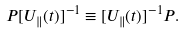Convert formula to latex. <formula><loc_0><loc_0><loc_500><loc_500>P [ U _ { \| } ( t ) ] ^ { - 1 } \equiv [ U _ { \| } ( t ) ] ^ { - 1 } P .</formula> 